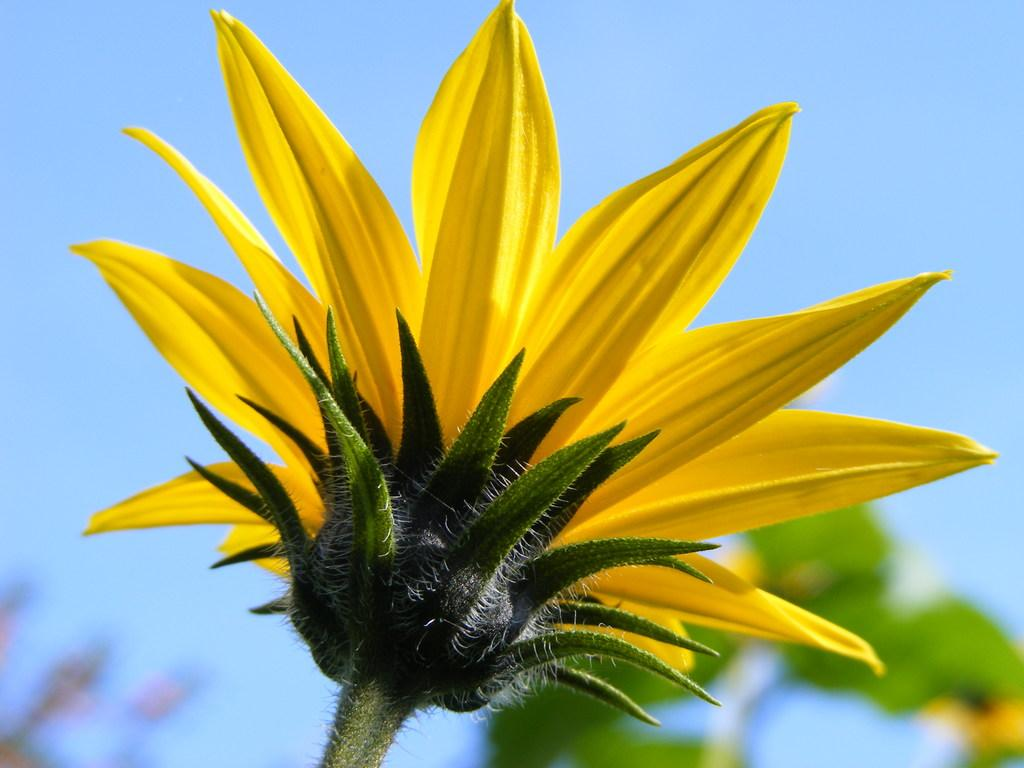What type of flower is in the image? There is a yellow color flower in the image. Can you describe the background of the image? The background of the image is blurred. How many pigs are visible in the image? There are no pigs present in the image. What type of board is used to support the flower in the image? There is no board present in the image; the flower is likely standing on its own or in a vase. 